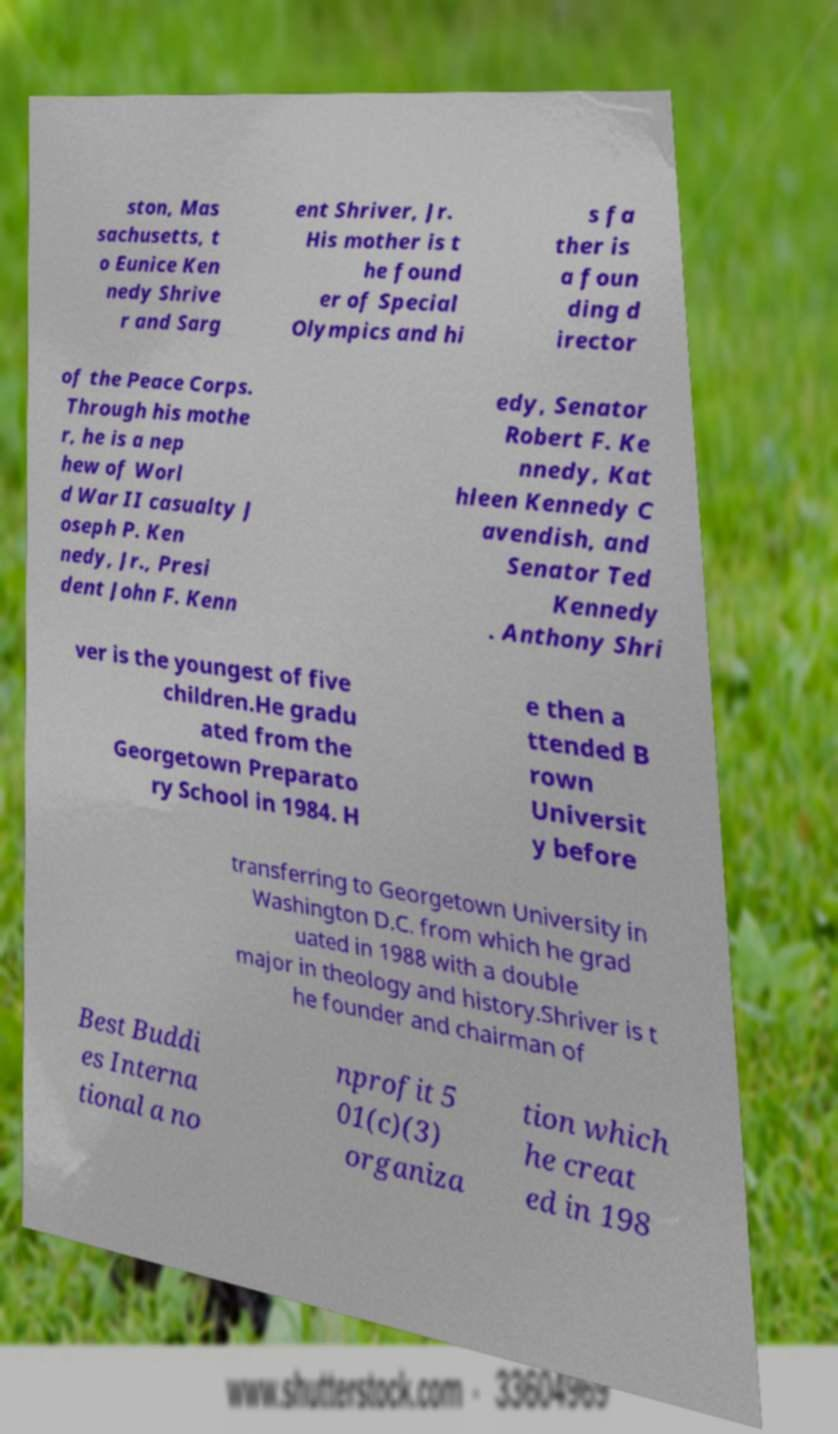Please read and relay the text visible in this image. What does it say? ston, Mas sachusetts, t o Eunice Ken nedy Shrive r and Sarg ent Shriver, Jr. His mother is t he found er of Special Olympics and hi s fa ther is a foun ding d irector of the Peace Corps. Through his mothe r, he is a nep hew of Worl d War II casualty J oseph P. Ken nedy, Jr., Presi dent John F. Kenn edy, Senator Robert F. Ke nnedy, Kat hleen Kennedy C avendish, and Senator Ted Kennedy . Anthony Shri ver is the youngest of five children.He gradu ated from the Georgetown Preparato ry School in 1984. H e then a ttended B rown Universit y before transferring to Georgetown University in Washington D.C. from which he grad uated in 1988 with a double major in theology and history.Shriver is t he founder and chairman of Best Buddi es Interna tional a no nprofit 5 01(c)(3) organiza tion which he creat ed in 198 